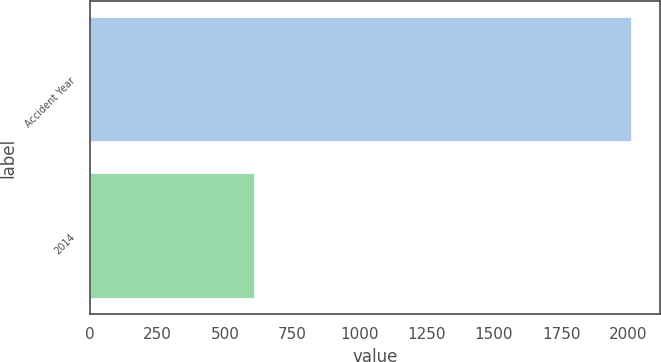Convert chart. <chart><loc_0><loc_0><loc_500><loc_500><bar_chart><fcel>Accident Year<fcel>2014<nl><fcel>2015<fcel>613<nl></chart> 